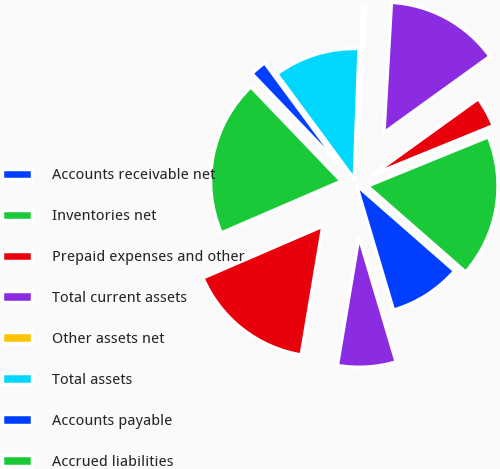Convert chart. <chart><loc_0><loc_0><loc_500><loc_500><pie_chart><fcel>Accounts receivable net<fcel>Inventories net<fcel>Prepaid expenses and other<fcel>Total current assets<fcel>Other assets net<fcel>Total assets<fcel>Accounts payable<fcel>Accrued liabilities<fcel>Total current liabilities<fcel>Retained earnings<nl><fcel>8.96%<fcel>17.6%<fcel>3.78%<fcel>14.15%<fcel>0.33%<fcel>10.69%<fcel>2.05%<fcel>19.33%<fcel>15.87%<fcel>7.24%<nl></chart> 